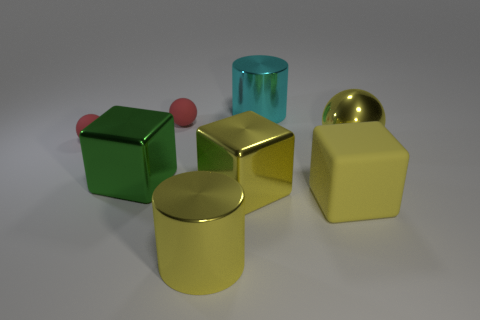There is a cylinder that is the same color as the big shiny sphere; what is its material?
Keep it short and to the point. Metal. There is a shiny thing that is behind the big shiny sphere; does it have the same shape as the green shiny thing?
Give a very brief answer. No. How many objects are big yellow blocks or large balls?
Your answer should be compact. 3. Does the ball on the right side of the yellow cylinder have the same material as the large green cube?
Offer a terse response. Yes. What is the size of the yellow rubber thing?
Offer a very short reply. Large. There is a big rubber thing that is the same color as the big metal ball; what is its shape?
Your answer should be very brief. Cube. What number of cylinders are either big metal things or cyan shiny things?
Give a very brief answer. 2. Is the number of spheres that are right of the large rubber cube the same as the number of big metallic things behind the big yellow shiny sphere?
Keep it short and to the point. Yes. What size is the yellow shiny thing that is the same shape as the big cyan metallic object?
Offer a very short reply. Large. How big is the yellow metal thing that is both on the left side of the large yellow rubber thing and behind the yellow cylinder?
Keep it short and to the point. Large. 